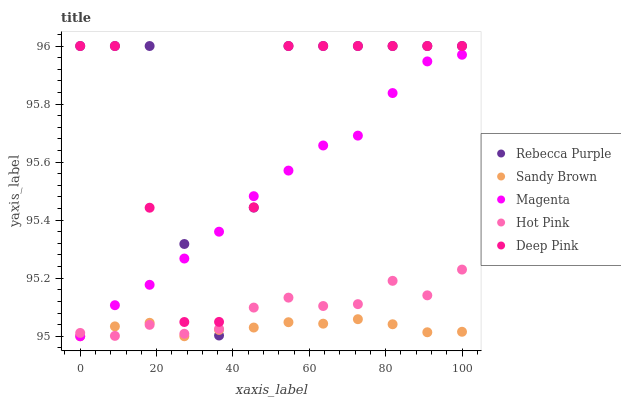Does Sandy Brown have the minimum area under the curve?
Answer yes or no. Yes. Does Rebecca Purple have the maximum area under the curve?
Answer yes or no. Yes. Does Hot Pink have the minimum area under the curve?
Answer yes or no. No. Does Hot Pink have the maximum area under the curve?
Answer yes or no. No. Is Sandy Brown the smoothest?
Answer yes or no. Yes. Is Rebecca Purple the roughest?
Answer yes or no. Yes. Is Hot Pink the smoothest?
Answer yes or no. No. Is Hot Pink the roughest?
Answer yes or no. No. Does Magenta have the lowest value?
Answer yes or no. Yes. Does Hot Pink have the lowest value?
Answer yes or no. No. Does Deep Pink have the highest value?
Answer yes or no. Yes. Does Hot Pink have the highest value?
Answer yes or no. No. Is Sandy Brown less than Deep Pink?
Answer yes or no. Yes. Is Deep Pink greater than Sandy Brown?
Answer yes or no. Yes. Does Magenta intersect Deep Pink?
Answer yes or no. Yes. Is Magenta less than Deep Pink?
Answer yes or no. No. Is Magenta greater than Deep Pink?
Answer yes or no. No. Does Sandy Brown intersect Deep Pink?
Answer yes or no. No. 